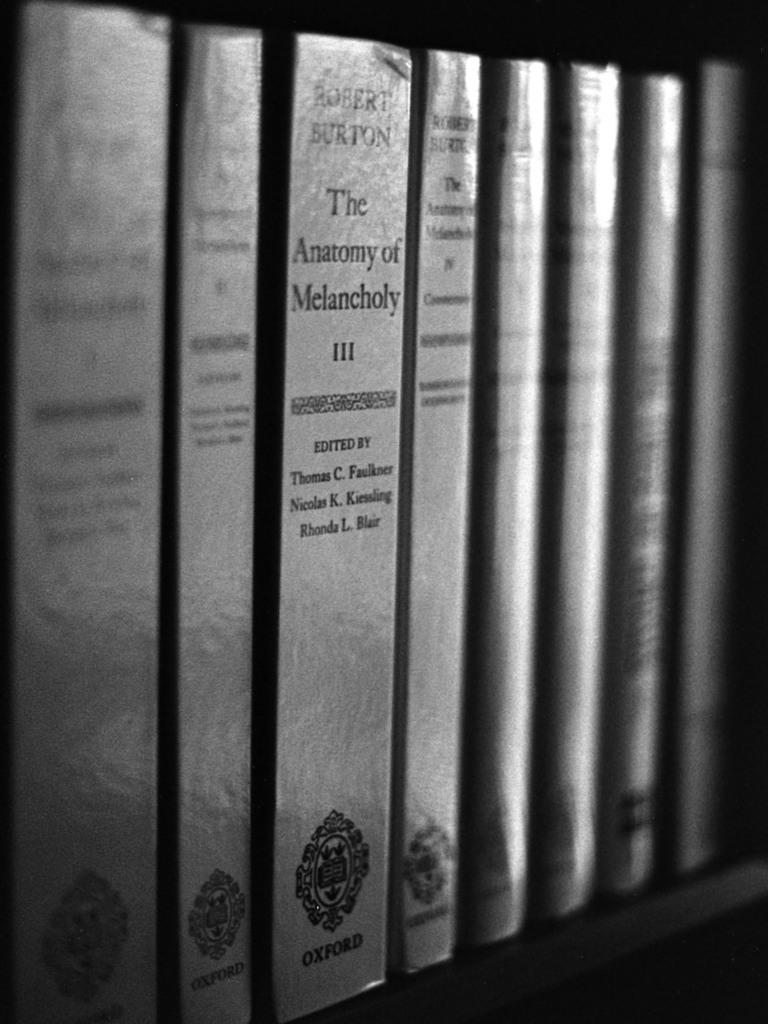<image>
Offer a succinct explanation of the picture presented. A book collection sitting upright with The Anatomy of Melancholy as one title. 